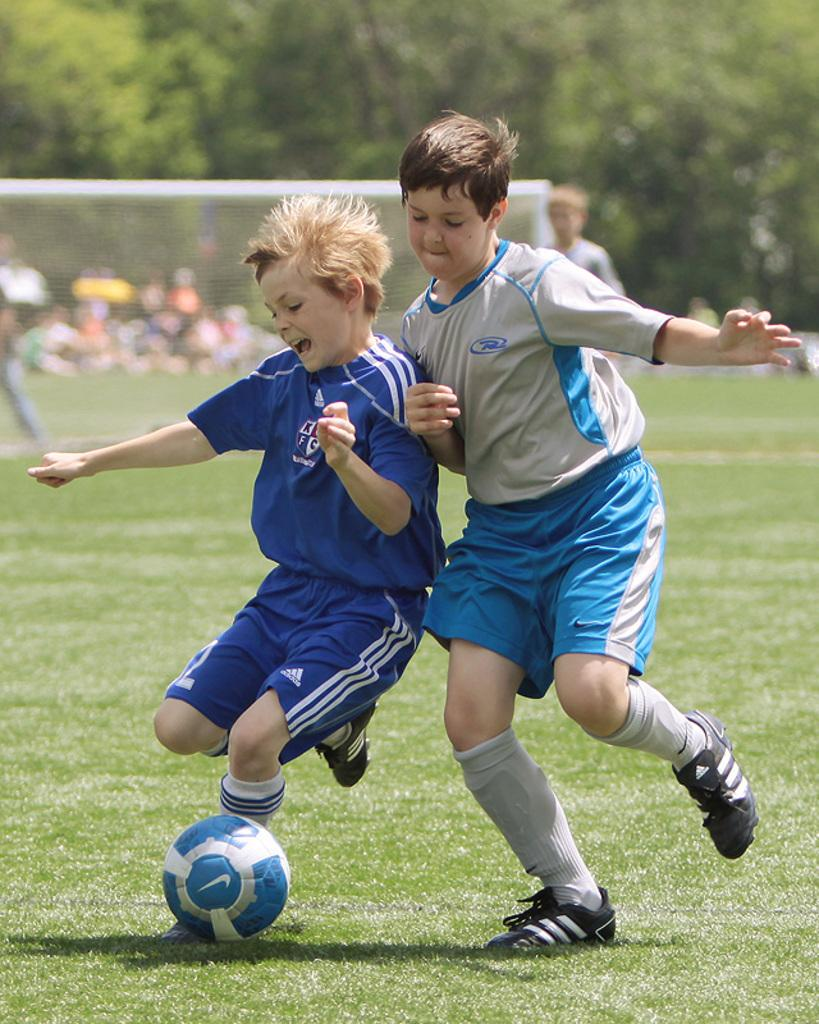Where is the image taken? The image is taken on the ground. What are the two boys in the center of the image doing? The two boys are playing football in the center of the image. What object is at the bottom of the image? There is a football at the bottom of the image. What can be seen in the background of the image? There are people, a net, and trees in the background of the image. What type of collar can be seen on the football in the image? There is no collar present on the football in the image. What kind of ray is visible in the background of the image? There is no ray visible in the image; it features a football game with people, a net, and trees in the background. 